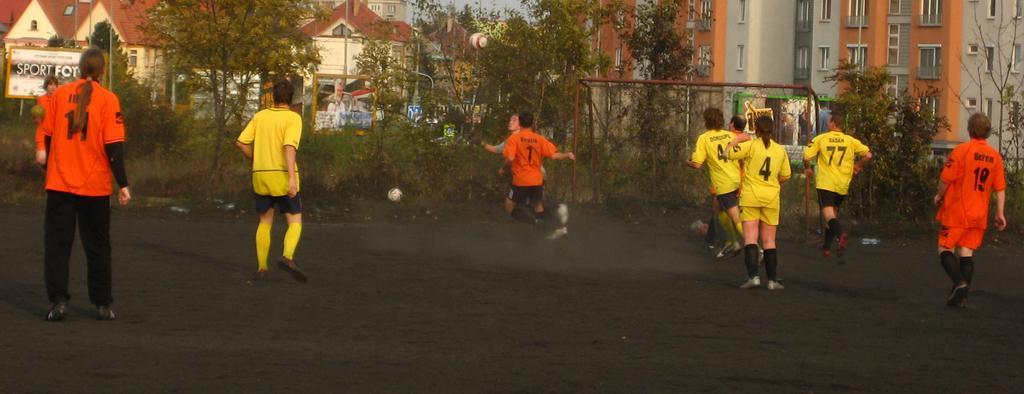How would you summarize this image in a sentence or two? There is a group of people playing football as we can see at the bottom of this image. We can see trees, balls, buildings and a goal net in the background. 